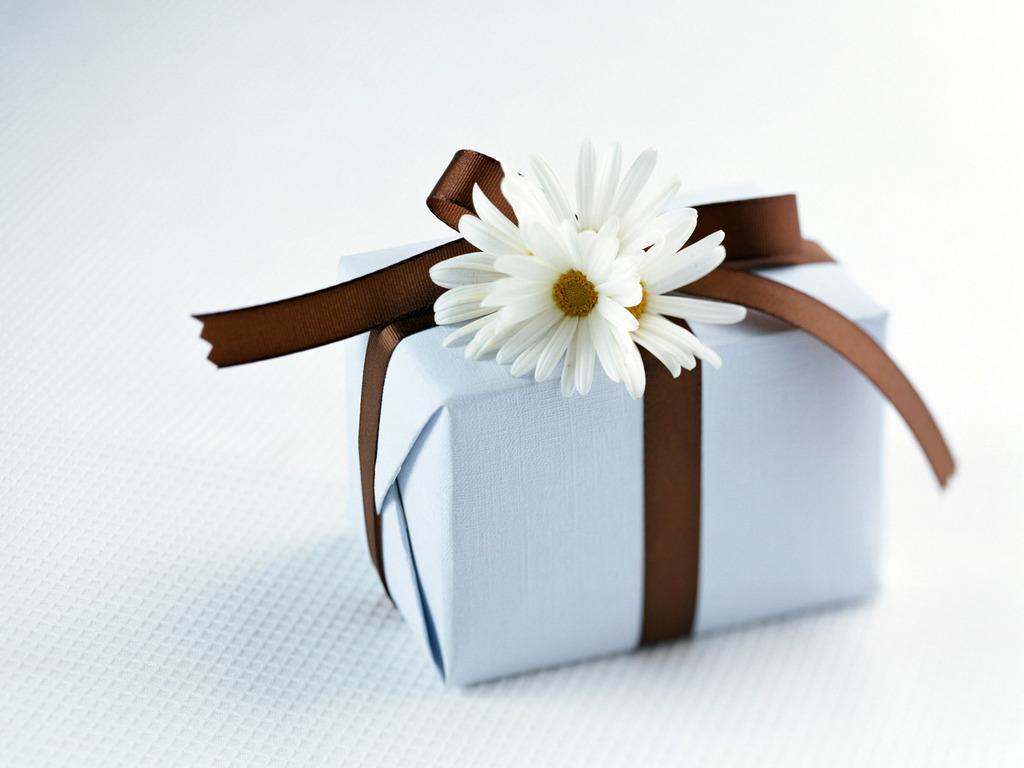Please provide a concise description of this image. There is a white gift box wrapped with a brown ribbon and there are white flowers on it. There is a white background. 